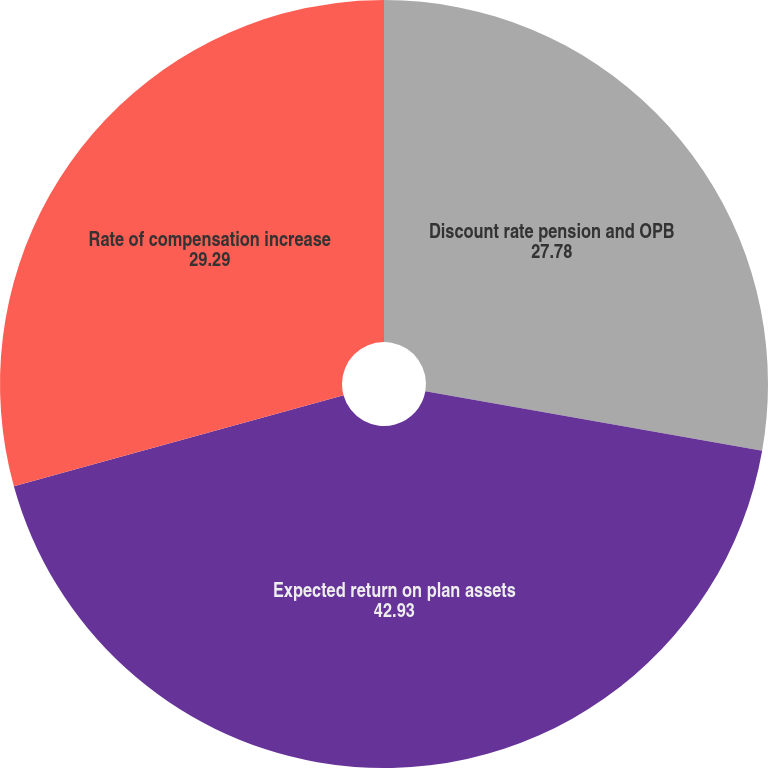Convert chart. <chart><loc_0><loc_0><loc_500><loc_500><pie_chart><fcel>Discount rate pension and OPB<fcel>Expected return on plan assets<fcel>Rate of compensation increase<nl><fcel>27.78%<fcel>42.93%<fcel>29.29%<nl></chart> 